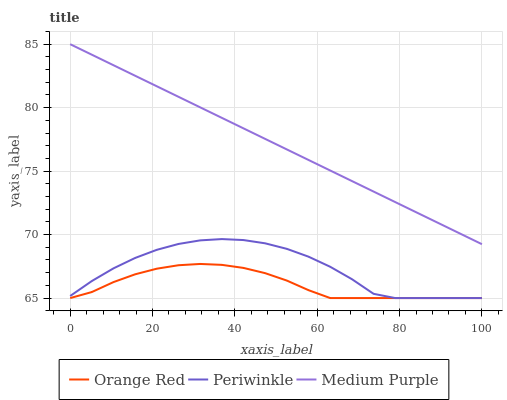Does Periwinkle have the minimum area under the curve?
Answer yes or no. No. Does Periwinkle have the maximum area under the curve?
Answer yes or no. No. Is Orange Red the smoothest?
Answer yes or no. No. Is Orange Red the roughest?
Answer yes or no. No. Does Periwinkle have the highest value?
Answer yes or no. No. Is Periwinkle less than Medium Purple?
Answer yes or no. Yes. Is Medium Purple greater than Periwinkle?
Answer yes or no. Yes. Does Periwinkle intersect Medium Purple?
Answer yes or no. No. 